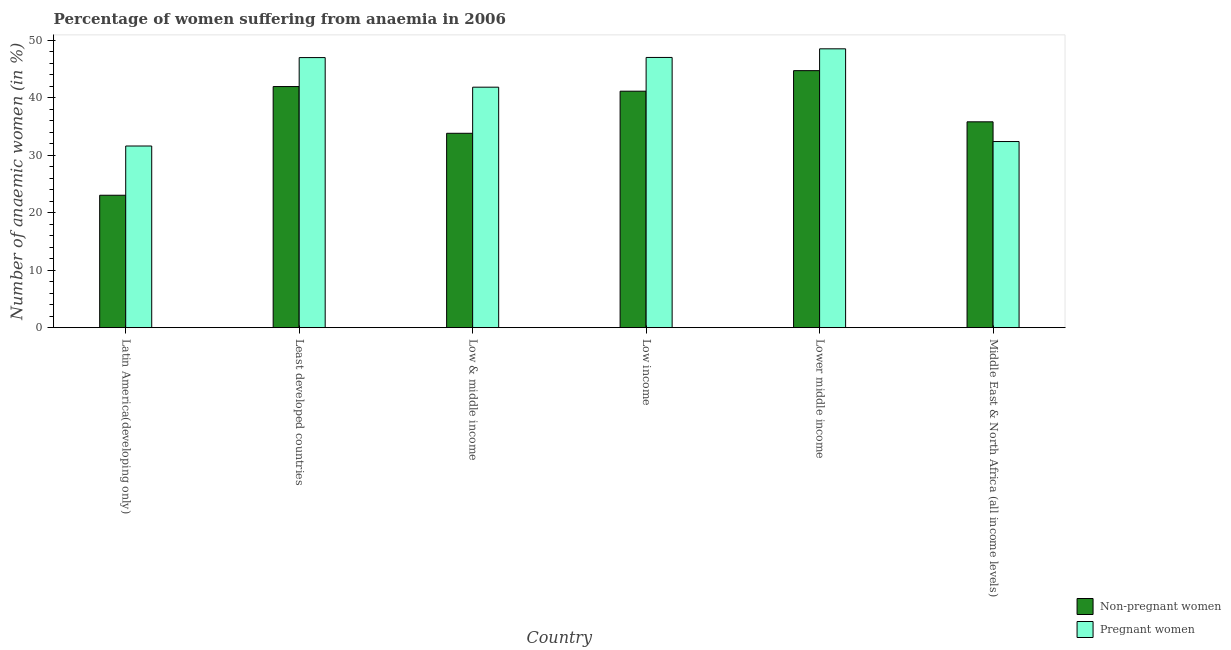How many groups of bars are there?
Offer a very short reply. 6. Are the number of bars per tick equal to the number of legend labels?
Offer a very short reply. Yes. Are the number of bars on each tick of the X-axis equal?
Provide a succinct answer. Yes. How many bars are there on the 6th tick from the right?
Provide a short and direct response. 2. What is the label of the 2nd group of bars from the left?
Provide a succinct answer. Least developed countries. What is the percentage of non-pregnant anaemic women in Low & middle income?
Ensure brevity in your answer.  33.81. Across all countries, what is the maximum percentage of pregnant anaemic women?
Provide a succinct answer. 48.51. Across all countries, what is the minimum percentage of non-pregnant anaemic women?
Your answer should be very brief. 23.04. In which country was the percentage of pregnant anaemic women maximum?
Keep it short and to the point. Lower middle income. In which country was the percentage of pregnant anaemic women minimum?
Your answer should be compact. Latin America(developing only). What is the total percentage of pregnant anaemic women in the graph?
Keep it short and to the point. 248.31. What is the difference between the percentage of non-pregnant anaemic women in Lower middle income and that in Middle East & North Africa (all income levels)?
Offer a very short reply. 8.9. What is the difference between the percentage of non-pregnant anaemic women in Low income and the percentage of pregnant anaemic women in Middle East & North Africa (all income levels)?
Offer a terse response. 8.76. What is the average percentage of pregnant anaemic women per country?
Give a very brief answer. 41.38. What is the difference between the percentage of pregnant anaemic women and percentage of non-pregnant anaemic women in Least developed countries?
Ensure brevity in your answer.  5.04. In how many countries, is the percentage of non-pregnant anaemic women greater than 32 %?
Your answer should be very brief. 5. What is the ratio of the percentage of pregnant anaemic women in Low income to that in Middle East & North Africa (all income levels)?
Your answer should be very brief. 1.45. What is the difference between the highest and the second highest percentage of non-pregnant anaemic women?
Your answer should be very brief. 2.77. What is the difference between the highest and the lowest percentage of pregnant anaemic women?
Your response must be concise. 16.91. What does the 1st bar from the left in Middle East & North Africa (all income levels) represents?
Make the answer very short. Non-pregnant women. What does the 1st bar from the right in Low & middle income represents?
Make the answer very short. Pregnant women. Are the values on the major ticks of Y-axis written in scientific E-notation?
Ensure brevity in your answer.  No. Where does the legend appear in the graph?
Keep it short and to the point. Bottom right. How are the legend labels stacked?
Give a very brief answer. Vertical. What is the title of the graph?
Your response must be concise. Percentage of women suffering from anaemia in 2006. Does "Pregnant women" appear as one of the legend labels in the graph?
Offer a very short reply. Yes. What is the label or title of the Y-axis?
Your response must be concise. Number of anaemic women (in %). What is the Number of anaemic women (in %) of Non-pregnant women in Latin America(developing only)?
Keep it short and to the point. 23.04. What is the Number of anaemic women (in %) in Pregnant women in Latin America(developing only)?
Keep it short and to the point. 31.6. What is the Number of anaemic women (in %) of Non-pregnant women in Least developed countries?
Offer a terse response. 41.94. What is the Number of anaemic women (in %) of Pregnant women in Least developed countries?
Provide a succinct answer. 46.98. What is the Number of anaemic women (in %) of Non-pregnant women in Low & middle income?
Your response must be concise. 33.81. What is the Number of anaemic women (in %) of Pregnant women in Low & middle income?
Ensure brevity in your answer.  41.83. What is the Number of anaemic women (in %) in Non-pregnant women in Low income?
Offer a terse response. 41.13. What is the Number of anaemic women (in %) of Pregnant women in Low income?
Provide a succinct answer. 47.01. What is the Number of anaemic women (in %) of Non-pregnant women in Lower middle income?
Offer a terse response. 44.71. What is the Number of anaemic women (in %) in Pregnant women in Lower middle income?
Make the answer very short. 48.51. What is the Number of anaemic women (in %) in Non-pregnant women in Middle East & North Africa (all income levels)?
Your response must be concise. 35.81. What is the Number of anaemic women (in %) in Pregnant women in Middle East & North Africa (all income levels)?
Give a very brief answer. 32.38. Across all countries, what is the maximum Number of anaemic women (in %) of Non-pregnant women?
Make the answer very short. 44.71. Across all countries, what is the maximum Number of anaemic women (in %) in Pregnant women?
Offer a terse response. 48.51. Across all countries, what is the minimum Number of anaemic women (in %) in Non-pregnant women?
Give a very brief answer. 23.04. Across all countries, what is the minimum Number of anaemic women (in %) of Pregnant women?
Provide a short and direct response. 31.6. What is the total Number of anaemic women (in %) in Non-pregnant women in the graph?
Make the answer very short. 220.44. What is the total Number of anaemic women (in %) of Pregnant women in the graph?
Keep it short and to the point. 248.31. What is the difference between the Number of anaemic women (in %) of Non-pregnant women in Latin America(developing only) and that in Least developed countries?
Keep it short and to the point. -18.91. What is the difference between the Number of anaemic women (in %) in Pregnant women in Latin America(developing only) and that in Least developed countries?
Provide a short and direct response. -15.38. What is the difference between the Number of anaemic women (in %) in Non-pregnant women in Latin America(developing only) and that in Low & middle income?
Make the answer very short. -10.78. What is the difference between the Number of anaemic women (in %) in Pregnant women in Latin America(developing only) and that in Low & middle income?
Provide a short and direct response. -10.24. What is the difference between the Number of anaemic women (in %) of Non-pregnant women in Latin America(developing only) and that in Low income?
Give a very brief answer. -18.1. What is the difference between the Number of anaemic women (in %) in Pregnant women in Latin America(developing only) and that in Low income?
Provide a succinct answer. -15.41. What is the difference between the Number of anaemic women (in %) of Non-pregnant women in Latin America(developing only) and that in Lower middle income?
Your answer should be compact. -21.67. What is the difference between the Number of anaemic women (in %) of Pregnant women in Latin America(developing only) and that in Lower middle income?
Your response must be concise. -16.91. What is the difference between the Number of anaemic women (in %) in Non-pregnant women in Latin America(developing only) and that in Middle East & North Africa (all income levels)?
Offer a terse response. -12.77. What is the difference between the Number of anaemic women (in %) in Pregnant women in Latin America(developing only) and that in Middle East & North Africa (all income levels)?
Give a very brief answer. -0.78. What is the difference between the Number of anaemic women (in %) in Non-pregnant women in Least developed countries and that in Low & middle income?
Your answer should be compact. 8.13. What is the difference between the Number of anaemic women (in %) in Pregnant women in Least developed countries and that in Low & middle income?
Provide a succinct answer. 5.15. What is the difference between the Number of anaemic women (in %) in Non-pregnant women in Least developed countries and that in Low income?
Give a very brief answer. 0.81. What is the difference between the Number of anaemic women (in %) in Pregnant women in Least developed countries and that in Low income?
Offer a terse response. -0.03. What is the difference between the Number of anaemic women (in %) in Non-pregnant women in Least developed countries and that in Lower middle income?
Your answer should be very brief. -2.77. What is the difference between the Number of anaemic women (in %) of Pregnant women in Least developed countries and that in Lower middle income?
Your answer should be compact. -1.53. What is the difference between the Number of anaemic women (in %) in Non-pregnant women in Least developed countries and that in Middle East & North Africa (all income levels)?
Offer a very short reply. 6.13. What is the difference between the Number of anaemic women (in %) in Pregnant women in Least developed countries and that in Middle East & North Africa (all income levels)?
Ensure brevity in your answer.  14.6. What is the difference between the Number of anaemic women (in %) of Non-pregnant women in Low & middle income and that in Low income?
Ensure brevity in your answer.  -7.32. What is the difference between the Number of anaemic women (in %) in Pregnant women in Low & middle income and that in Low income?
Offer a very short reply. -5.17. What is the difference between the Number of anaemic women (in %) of Non-pregnant women in Low & middle income and that in Lower middle income?
Provide a succinct answer. -10.9. What is the difference between the Number of anaemic women (in %) of Pregnant women in Low & middle income and that in Lower middle income?
Provide a succinct answer. -6.67. What is the difference between the Number of anaemic women (in %) in Non-pregnant women in Low & middle income and that in Middle East & North Africa (all income levels)?
Provide a succinct answer. -2. What is the difference between the Number of anaemic women (in %) in Pregnant women in Low & middle income and that in Middle East & North Africa (all income levels)?
Keep it short and to the point. 9.46. What is the difference between the Number of anaemic women (in %) in Non-pregnant women in Low income and that in Lower middle income?
Your answer should be very brief. -3.57. What is the difference between the Number of anaemic women (in %) of Pregnant women in Low income and that in Lower middle income?
Keep it short and to the point. -1.5. What is the difference between the Number of anaemic women (in %) in Non-pregnant women in Low income and that in Middle East & North Africa (all income levels)?
Your answer should be compact. 5.33. What is the difference between the Number of anaemic women (in %) of Pregnant women in Low income and that in Middle East & North Africa (all income levels)?
Your answer should be compact. 14.63. What is the difference between the Number of anaemic women (in %) in Non-pregnant women in Lower middle income and that in Middle East & North Africa (all income levels)?
Offer a terse response. 8.9. What is the difference between the Number of anaemic women (in %) in Pregnant women in Lower middle income and that in Middle East & North Africa (all income levels)?
Your answer should be very brief. 16.13. What is the difference between the Number of anaemic women (in %) in Non-pregnant women in Latin America(developing only) and the Number of anaemic women (in %) in Pregnant women in Least developed countries?
Give a very brief answer. -23.95. What is the difference between the Number of anaemic women (in %) in Non-pregnant women in Latin America(developing only) and the Number of anaemic women (in %) in Pregnant women in Low & middle income?
Provide a short and direct response. -18.8. What is the difference between the Number of anaemic women (in %) in Non-pregnant women in Latin America(developing only) and the Number of anaemic women (in %) in Pregnant women in Low income?
Provide a short and direct response. -23.97. What is the difference between the Number of anaemic women (in %) in Non-pregnant women in Latin America(developing only) and the Number of anaemic women (in %) in Pregnant women in Lower middle income?
Provide a short and direct response. -25.47. What is the difference between the Number of anaemic women (in %) in Non-pregnant women in Latin America(developing only) and the Number of anaemic women (in %) in Pregnant women in Middle East & North Africa (all income levels)?
Provide a short and direct response. -9.34. What is the difference between the Number of anaemic women (in %) of Non-pregnant women in Least developed countries and the Number of anaemic women (in %) of Pregnant women in Low & middle income?
Offer a terse response. 0.11. What is the difference between the Number of anaemic women (in %) in Non-pregnant women in Least developed countries and the Number of anaemic women (in %) in Pregnant women in Low income?
Keep it short and to the point. -5.07. What is the difference between the Number of anaemic women (in %) in Non-pregnant women in Least developed countries and the Number of anaemic women (in %) in Pregnant women in Lower middle income?
Make the answer very short. -6.57. What is the difference between the Number of anaemic women (in %) in Non-pregnant women in Least developed countries and the Number of anaemic women (in %) in Pregnant women in Middle East & North Africa (all income levels)?
Your answer should be compact. 9.56. What is the difference between the Number of anaemic women (in %) of Non-pregnant women in Low & middle income and the Number of anaemic women (in %) of Pregnant women in Low income?
Give a very brief answer. -13.2. What is the difference between the Number of anaemic women (in %) in Non-pregnant women in Low & middle income and the Number of anaemic women (in %) in Pregnant women in Lower middle income?
Give a very brief answer. -14.7. What is the difference between the Number of anaemic women (in %) in Non-pregnant women in Low & middle income and the Number of anaemic women (in %) in Pregnant women in Middle East & North Africa (all income levels)?
Your response must be concise. 1.43. What is the difference between the Number of anaemic women (in %) in Non-pregnant women in Low income and the Number of anaemic women (in %) in Pregnant women in Lower middle income?
Provide a short and direct response. -7.37. What is the difference between the Number of anaemic women (in %) of Non-pregnant women in Low income and the Number of anaemic women (in %) of Pregnant women in Middle East & North Africa (all income levels)?
Your answer should be compact. 8.76. What is the difference between the Number of anaemic women (in %) in Non-pregnant women in Lower middle income and the Number of anaemic women (in %) in Pregnant women in Middle East & North Africa (all income levels)?
Keep it short and to the point. 12.33. What is the average Number of anaemic women (in %) in Non-pregnant women per country?
Make the answer very short. 36.74. What is the average Number of anaemic women (in %) in Pregnant women per country?
Your response must be concise. 41.38. What is the difference between the Number of anaemic women (in %) of Non-pregnant women and Number of anaemic women (in %) of Pregnant women in Latin America(developing only)?
Keep it short and to the point. -8.56. What is the difference between the Number of anaemic women (in %) in Non-pregnant women and Number of anaemic women (in %) in Pregnant women in Least developed countries?
Your answer should be very brief. -5.04. What is the difference between the Number of anaemic women (in %) in Non-pregnant women and Number of anaemic women (in %) in Pregnant women in Low & middle income?
Give a very brief answer. -8.02. What is the difference between the Number of anaemic women (in %) of Non-pregnant women and Number of anaemic women (in %) of Pregnant women in Low income?
Your response must be concise. -5.87. What is the difference between the Number of anaemic women (in %) in Non-pregnant women and Number of anaemic women (in %) in Pregnant women in Lower middle income?
Your answer should be very brief. -3.8. What is the difference between the Number of anaemic women (in %) in Non-pregnant women and Number of anaemic women (in %) in Pregnant women in Middle East & North Africa (all income levels)?
Make the answer very short. 3.43. What is the ratio of the Number of anaemic women (in %) in Non-pregnant women in Latin America(developing only) to that in Least developed countries?
Offer a very short reply. 0.55. What is the ratio of the Number of anaemic women (in %) of Pregnant women in Latin America(developing only) to that in Least developed countries?
Offer a very short reply. 0.67. What is the ratio of the Number of anaemic women (in %) of Non-pregnant women in Latin America(developing only) to that in Low & middle income?
Offer a very short reply. 0.68. What is the ratio of the Number of anaemic women (in %) in Pregnant women in Latin America(developing only) to that in Low & middle income?
Your response must be concise. 0.76. What is the ratio of the Number of anaemic women (in %) in Non-pregnant women in Latin America(developing only) to that in Low income?
Offer a very short reply. 0.56. What is the ratio of the Number of anaemic women (in %) in Pregnant women in Latin America(developing only) to that in Low income?
Provide a succinct answer. 0.67. What is the ratio of the Number of anaemic women (in %) in Non-pregnant women in Latin America(developing only) to that in Lower middle income?
Your response must be concise. 0.52. What is the ratio of the Number of anaemic women (in %) of Pregnant women in Latin America(developing only) to that in Lower middle income?
Keep it short and to the point. 0.65. What is the ratio of the Number of anaemic women (in %) in Non-pregnant women in Latin America(developing only) to that in Middle East & North Africa (all income levels)?
Ensure brevity in your answer.  0.64. What is the ratio of the Number of anaemic women (in %) of Pregnant women in Latin America(developing only) to that in Middle East & North Africa (all income levels)?
Provide a short and direct response. 0.98. What is the ratio of the Number of anaemic women (in %) in Non-pregnant women in Least developed countries to that in Low & middle income?
Make the answer very short. 1.24. What is the ratio of the Number of anaemic women (in %) of Pregnant women in Least developed countries to that in Low & middle income?
Keep it short and to the point. 1.12. What is the ratio of the Number of anaemic women (in %) in Non-pregnant women in Least developed countries to that in Low income?
Ensure brevity in your answer.  1.02. What is the ratio of the Number of anaemic women (in %) of Pregnant women in Least developed countries to that in Low income?
Offer a very short reply. 1. What is the ratio of the Number of anaemic women (in %) in Non-pregnant women in Least developed countries to that in Lower middle income?
Provide a succinct answer. 0.94. What is the ratio of the Number of anaemic women (in %) in Pregnant women in Least developed countries to that in Lower middle income?
Keep it short and to the point. 0.97. What is the ratio of the Number of anaemic women (in %) of Non-pregnant women in Least developed countries to that in Middle East & North Africa (all income levels)?
Ensure brevity in your answer.  1.17. What is the ratio of the Number of anaemic women (in %) of Pregnant women in Least developed countries to that in Middle East & North Africa (all income levels)?
Offer a terse response. 1.45. What is the ratio of the Number of anaemic women (in %) of Non-pregnant women in Low & middle income to that in Low income?
Offer a very short reply. 0.82. What is the ratio of the Number of anaemic women (in %) in Pregnant women in Low & middle income to that in Low income?
Provide a succinct answer. 0.89. What is the ratio of the Number of anaemic women (in %) of Non-pregnant women in Low & middle income to that in Lower middle income?
Give a very brief answer. 0.76. What is the ratio of the Number of anaemic women (in %) of Pregnant women in Low & middle income to that in Lower middle income?
Keep it short and to the point. 0.86. What is the ratio of the Number of anaemic women (in %) in Non-pregnant women in Low & middle income to that in Middle East & North Africa (all income levels)?
Offer a very short reply. 0.94. What is the ratio of the Number of anaemic women (in %) of Pregnant women in Low & middle income to that in Middle East & North Africa (all income levels)?
Offer a terse response. 1.29. What is the ratio of the Number of anaemic women (in %) in Non-pregnant women in Low income to that in Lower middle income?
Offer a very short reply. 0.92. What is the ratio of the Number of anaemic women (in %) of Pregnant women in Low income to that in Lower middle income?
Offer a very short reply. 0.97. What is the ratio of the Number of anaemic women (in %) of Non-pregnant women in Low income to that in Middle East & North Africa (all income levels)?
Your response must be concise. 1.15. What is the ratio of the Number of anaemic women (in %) in Pregnant women in Low income to that in Middle East & North Africa (all income levels)?
Offer a terse response. 1.45. What is the ratio of the Number of anaemic women (in %) in Non-pregnant women in Lower middle income to that in Middle East & North Africa (all income levels)?
Provide a succinct answer. 1.25. What is the ratio of the Number of anaemic women (in %) of Pregnant women in Lower middle income to that in Middle East & North Africa (all income levels)?
Offer a very short reply. 1.5. What is the difference between the highest and the second highest Number of anaemic women (in %) in Non-pregnant women?
Give a very brief answer. 2.77. What is the difference between the highest and the second highest Number of anaemic women (in %) in Pregnant women?
Your response must be concise. 1.5. What is the difference between the highest and the lowest Number of anaemic women (in %) in Non-pregnant women?
Your answer should be very brief. 21.67. What is the difference between the highest and the lowest Number of anaemic women (in %) in Pregnant women?
Offer a very short reply. 16.91. 